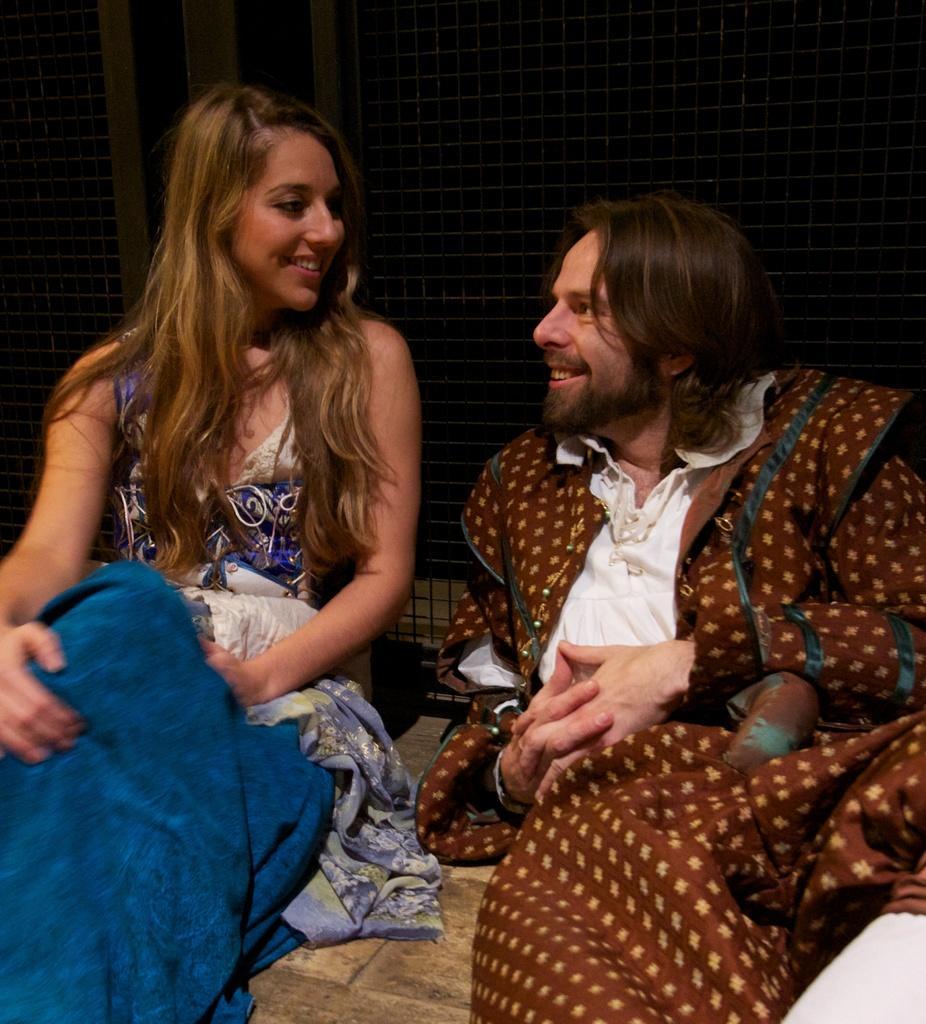Can you describe this image briefly? In this image, we can see a man and a lady sitting and smiling. 